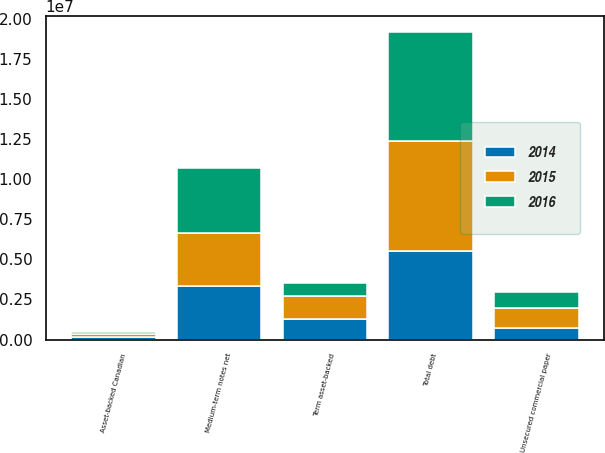<chart> <loc_0><loc_0><loc_500><loc_500><stacked_bar_chart><ecel><fcel>Unsecured commercial paper<fcel>Asset-backed Canadian<fcel>Medium-term notes net<fcel>Term asset-backed<fcel>Total debt<nl><fcel>2016<fcel>1.05571e+06<fcel>149338<fcel>4.06494e+06<fcel>796275<fcel>6.80757e+06<nl><fcel>2015<fcel>1.20138e+06<fcel>153839<fcel>3.31695e+06<fcel>1.45938e+06<fcel>6.8722e+06<nl><fcel>2014<fcel>731786<fcel>166912<fcel>3.32528e+06<fcel>1.26842e+06<fcel>5.4924e+06<nl></chart> 